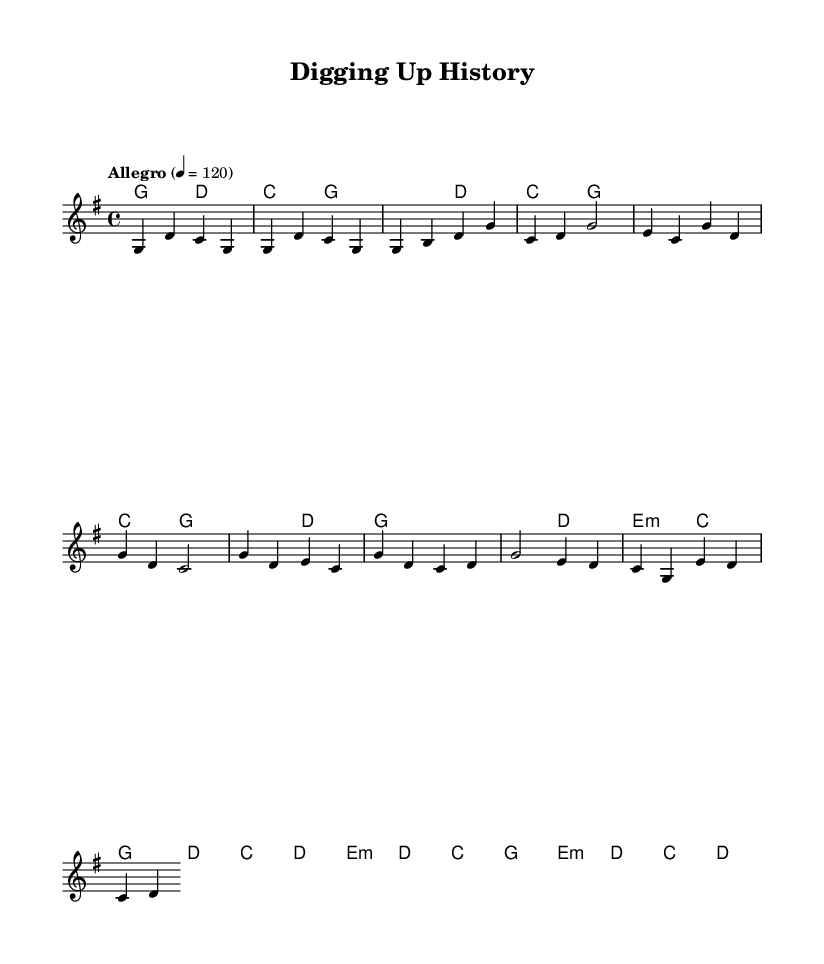What is the key signature of this music? The key signature is G major, which has one sharp (F#). This can be determined by looking at the key signature indicated at the beginning of the music.
Answer: G major What is the time signature of the piece? The time signature is 4/4, which is indicated at the beginning of the score. This means there are four beats in each measure and the quarter note receives one beat.
Answer: 4/4 What is the tempo marking in this music? The tempo marking is "Allegro," which indicates a fast and lively tempo. Additionally, it specifies a metronome marking of 120 beats per minute. This information is typically found right after the time signature.
Answer: Allegro How many measures are there in the chorus section? The chorus section consists of four measures. By counting the measures indicated in the music score, specifically the section labeled as "Chorus," we can confirm that there are four distinct measures present.
Answer: Four What chords are used in the bridge section? The chords used in the bridge section are E minor, D, C, and G. By looking at the chord symbols written above the melody, we can identify these specific chords that accompany this part of the song.
Answer: E minor, D, C, G What mood does the melody suggest based on its notes? The melody suggests an upbeat and cheerful mood; this is evident because it utilizes rising melodic lines and major harmonies that are typical characteristics of many country songs. The combination of notes conveys a sense of celebration and excitement, often associated with discoveries and achievements.
Answer: Upbeat 